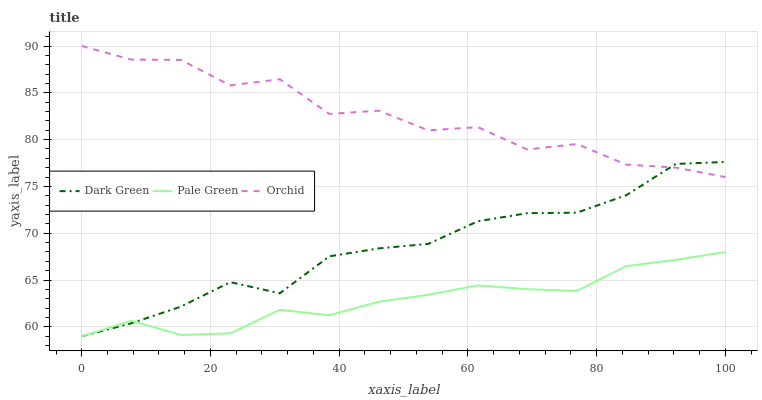Does Pale Green have the minimum area under the curve?
Answer yes or no. Yes. Does Orchid have the maximum area under the curve?
Answer yes or no. Yes. Does Dark Green have the minimum area under the curve?
Answer yes or no. No. Does Dark Green have the maximum area under the curve?
Answer yes or no. No. Is Pale Green the smoothest?
Answer yes or no. Yes. Is Orchid the roughest?
Answer yes or no. Yes. Is Dark Green the smoothest?
Answer yes or no. No. Is Dark Green the roughest?
Answer yes or no. No. Does Pale Green have the lowest value?
Answer yes or no. Yes. Does Orchid have the highest value?
Answer yes or no. Yes. Does Dark Green have the highest value?
Answer yes or no. No. Is Pale Green less than Orchid?
Answer yes or no. Yes. Is Orchid greater than Pale Green?
Answer yes or no. Yes. Does Dark Green intersect Orchid?
Answer yes or no. Yes. Is Dark Green less than Orchid?
Answer yes or no. No. Is Dark Green greater than Orchid?
Answer yes or no. No. Does Pale Green intersect Orchid?
Answer yes or no. No. 